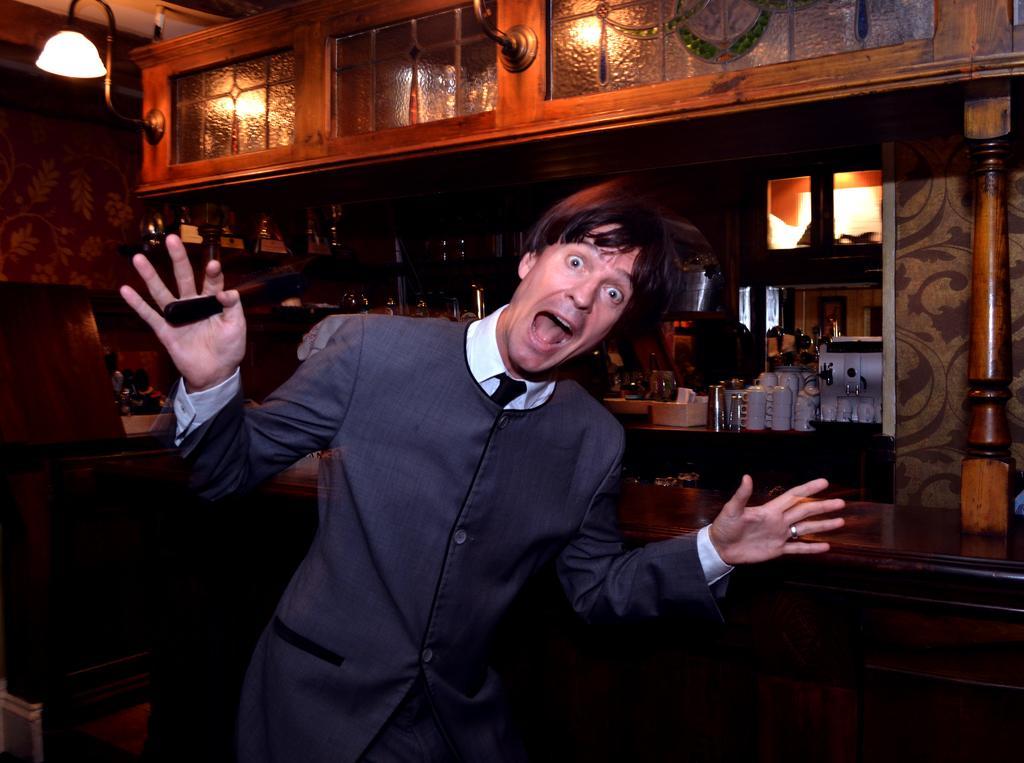Can you describe this image briefly? In front of the image there is a person holding some object in his hand, behind the person there is a wooden platform, on the other side of the wooden platform, there are some objects, at the top of the image there are lamps and glass windows. In the background of the image there is a wall. 